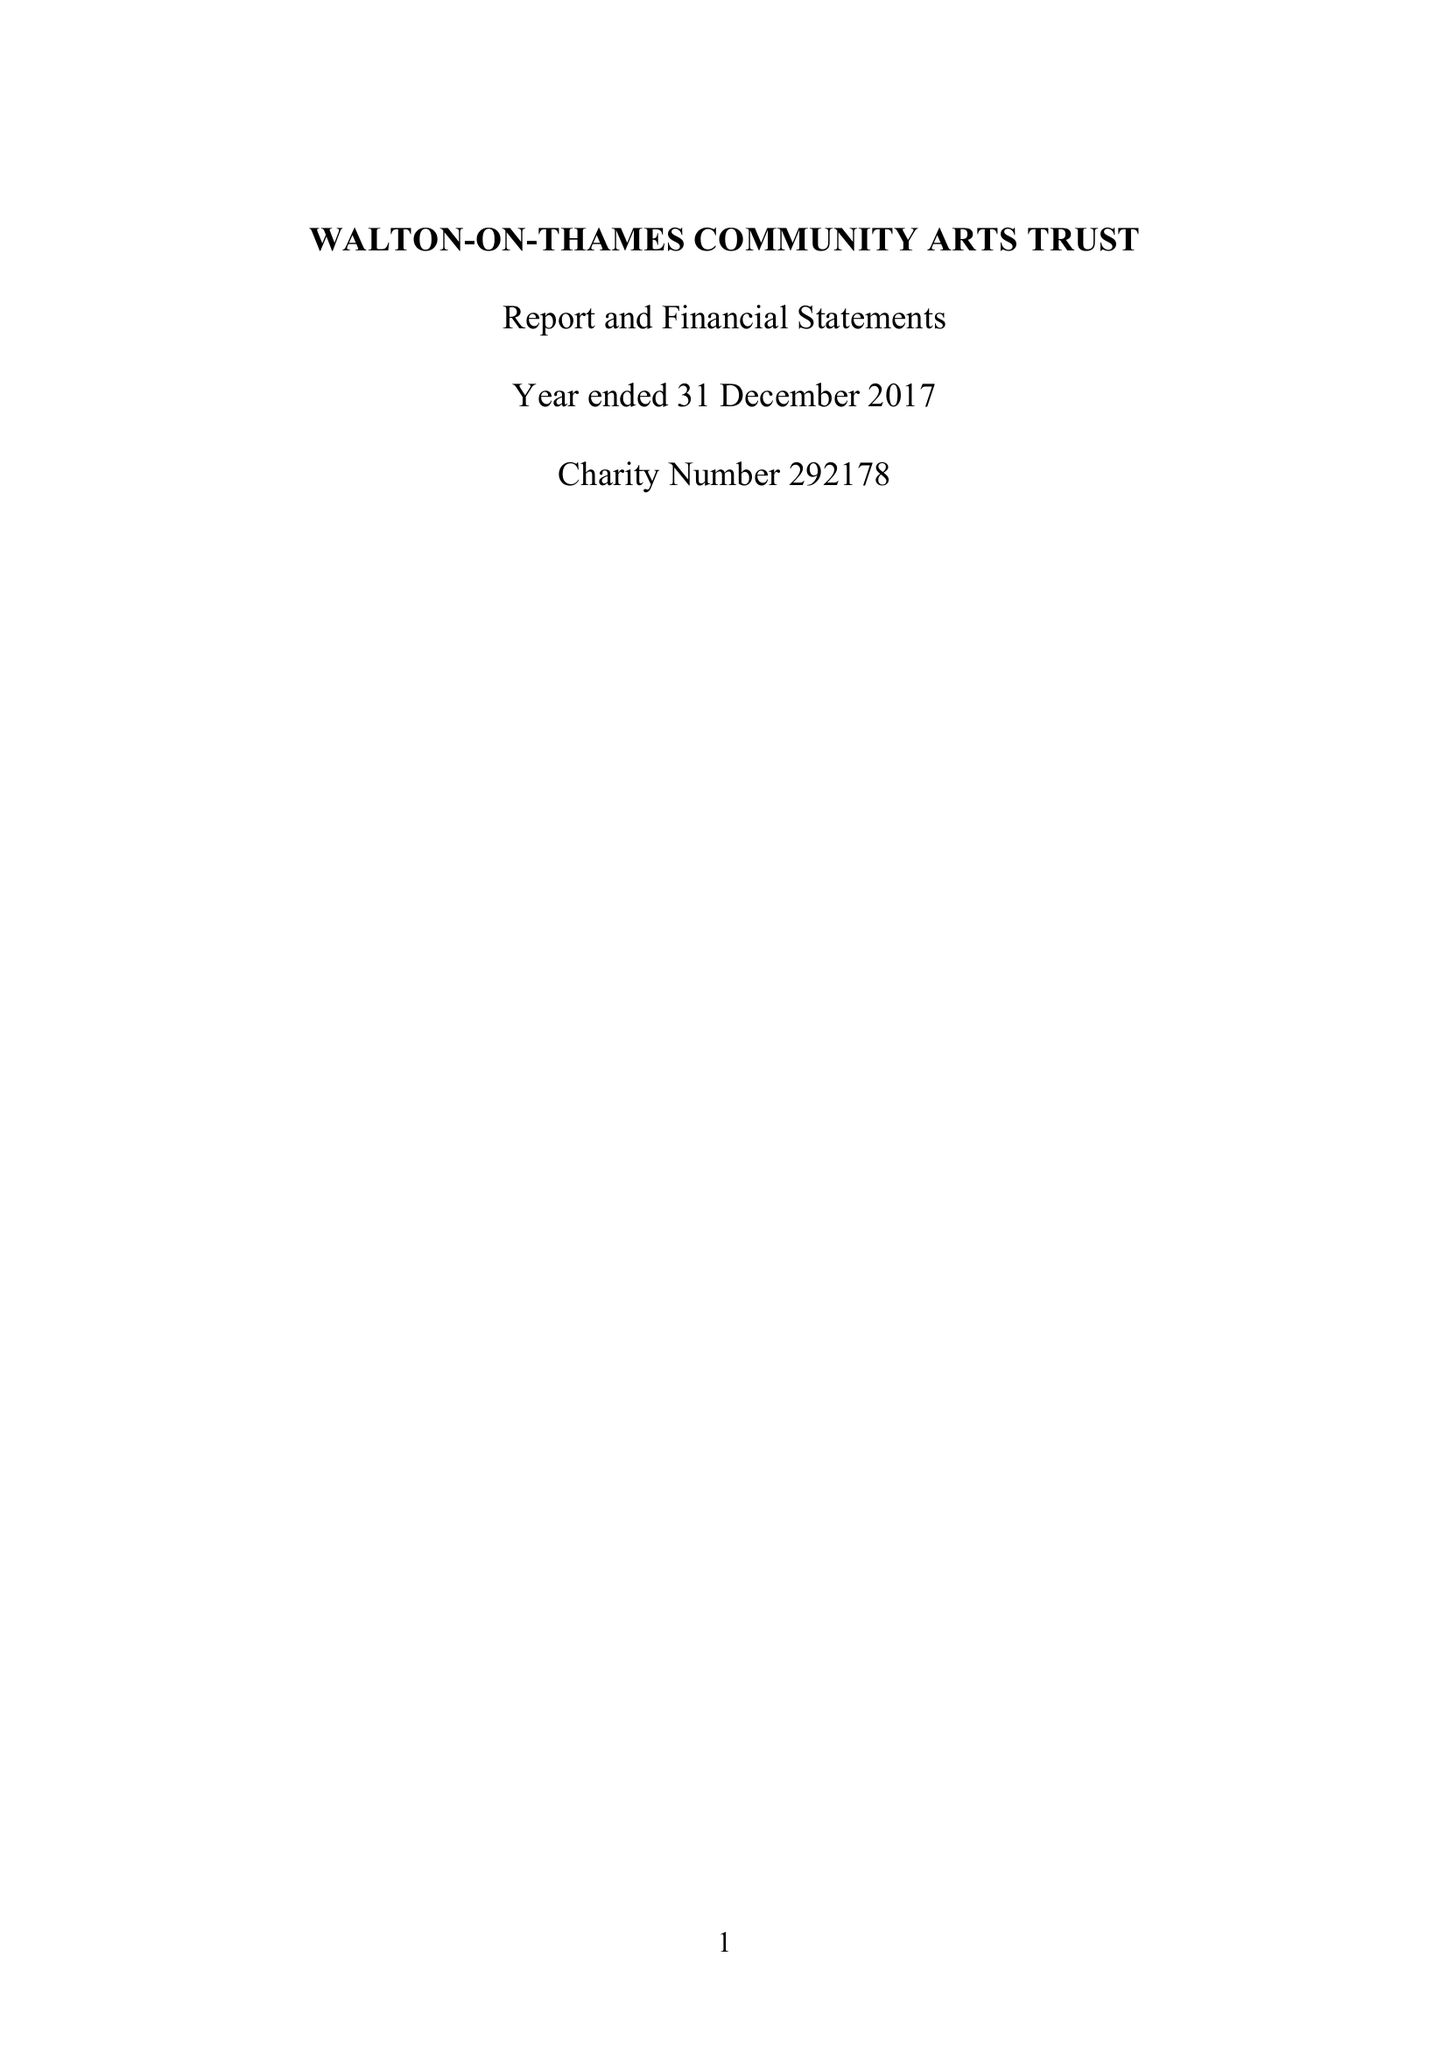What is the value for the spending_annually_in_british_pounds?
Answer the question using a single word or phrase. 42450.00 